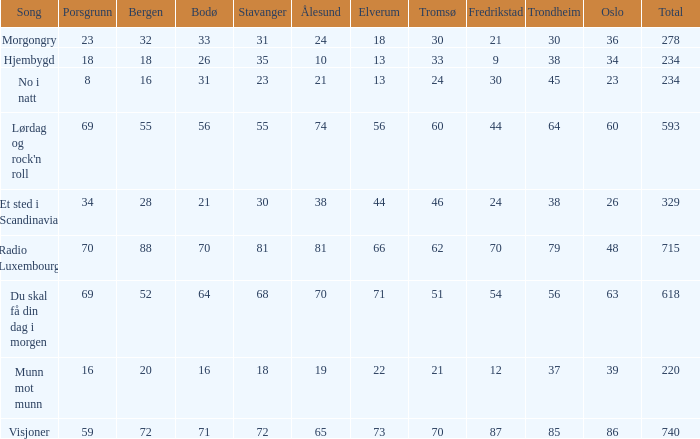What is the lowest total? 220.0. 